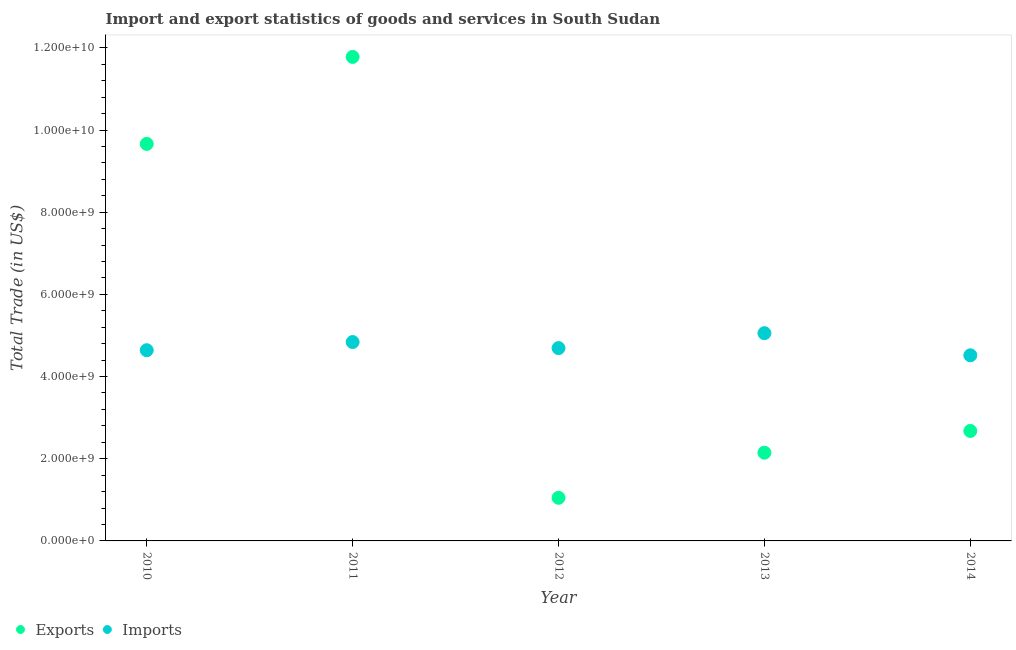How many different coloured dotlines are there?
Provide a short and direct response. 2. What is the imports of goods and services in 2012?
Give a very brief answer. 4.69e+09. Across all years, what is the maximum export of goods and services?
Your response must be concise. 1.18e+1. Across all years, what is the minimum imports of goods and services?
Your response must be concise. 4.52e+09. In which year was the imports of goods and services maximum?
Ensure brevity in your answer.  2013. What is the total export of goods and services in the graph?
Your answer should be very brief. 2.73e+1. What is the difference between the export of goods and services in 2010 and that in 2014?
Your answer should be very brief. 6.99e+09. What is the difference between the export of goods and services in 2011 and the imports of goods and services in 2014?
Provide a short and direct response. 7.26e+09. What is the average imports of goods and services per year?
Your answer should be very brief. 4.75e+09. In the year 2010, what is the difference between the imports of goods and services and export of goods and services?
Your answer should be very brief. -5.02e+09. What is the ratio of the imports of goods and services in 2010 to that in 2014?
Make the answer very short. 1.03. Is the difference between the imports of goods and services in 2012 and 2013 greater than the difference between the export of goods and services in 2012 and 2013?
Offer a terse response. Yes. What is the difference between the highest and the second highest export of goods and services?
Provide a succinct answer. 2.12e+09. What is the difference between the highest and the lowest export of goods and services?
Your answer should be compact. 1.07e+1. How many dotlines are there?
Make the answer very short. 2. How many years are there in the graph?
Your answer should be compact. 5. What is the difference between two consecutive major ticks on the Y-axis?
Your answer should be compact. 2.00e+09. Are the values on the major ticks of Y-axis written in scientific E-notation?
Make the answer very short. Yes. How many legend labels are there?
Give a very brief answer. 2. What is the title of the graph?
Your answer should be very brief. Import and export statistics of goods and services in South Sudan. What is the label or title of the Y-axis?
Provide a short and direct response. Total Trade (in US$). What is the Total Trade (in US$) in Exports in 2010?
Your answer should be very brief. 9.66e+09. What is the Total Trade (in US$) of Imports in 2010?
Your response must be concise. 4.64e+09. What is the Total Trade (in US$) of Exports in 2011?
Make the answer very short. 1.18e+1. What is the Total Trade (in US$) in Imports in 2011?
Your answer should be compact. 4.84e+09. What is the Total Trade (in US$) of Exports in 2012?
Your response must be concise. 1.05e+09. What is the Total Trade (in US$) in Imports in 2012?
Make the answer very short. 4.69e+09. What is the Total Trade (in US$) in Exports in 2013?
Your response must be concise. 2.15e+09. What is the Total Trade (in US$) in Imports in 2013?
Give a very brief answer. 5.06e+09. What is the Total Trade (in US$) of Exports in 2014?
Provide a succinct answer. 2.68e+09. What is the Total Trade (in US$) of Imports in 2014?
Your answer should be very brief. 4.52e+09. Across all years, what is the maximum Total Trade (in US$) in Exports?
Your answer should be compact. 1.18e+1. Across all years, what is the maximum Total Trade (in US$) in Imports?
Provide a succinct answer. 5.06e+09. Across all years, what is the minimum Total Trade (in US$) of Exports?
Offer a very short reply. 1.05e+09. Across all years, what is the minimum Total Trade (in US$) of Imports?
Provide a succinct answer. 4.52e+09. What is the total Total Trade (in US$) of Exports in the graph?
Offer a very short reply. 2.73e+1. What is the total Total Trade (in US$) in Imports in the graph?
Provide a short and direct response. 2.37e+1. What is the difference between the Total Trade (in US$) in Exports in 2010 and that in 2011?
Make the answer very short. -2.12e+09. What is the difference between the Total Trade (in US$) of Imports in 2010 and that in 2011?
Your response must be concise. -1.99e+08. What is the difference between the Total Trade (in US$) in Exports in 2010 and that in 2012?
Offer a terse response. 8.61e+09. What is the difference between the Total Trade (in US$) of Imports in 2010 and that in 2012?
Make the answer very short. -5.19e+07. What is the difference between the Total Trade (in US$) in Exports in 2010 and that in 2013?
Offer a very short reply. 7.51e+09. What is the difference between the Total Trade (in US$) in Imports in 2010 and that in 2013?
Make the answer very short. -4.15e+08. What is the difference between the Total Trade (in US$) of Exports in 2010 and that in 2014?
Your response must be concise. 6.99e+09. What is the difference between the Total Trade (in US$) in Imports in 2010 and that in 2014?
Ensure brevity in your answer.  1.23e+08. What is the difference between the Total Trade (in US$) of Exports in 2011 and that in 2012?
Provide a short and direct response. 1.07e+1. What is the difference between the Total Trade (in US$) of Imports in 2011 and that in 2012?
Provide a succinct answer. 1.47e+08. What is the difference between the Total Trade (in US$) in Exports in 2011 and that in 2013?
Provide a succinct answer. 9.63e+09. What is the difference between the Total Trade (in US$) of Imports in 2011 and that in 2013?
Provide a succinct answer. -2.16e+08. What is the difference between the Total Trade (in US$) of Exports in 2011 and that in 2014?
Ensure brevity in your answer.  9.10e+09. What is the difference between the Total Trade (in US$) in Imports in 2011 and that in 2014?
Offer a terse response. 3.22e+08. What is the difference between the Total Trade (in US$) of Exports in 2012 and that in 2013?
Offer a terse response. -1.10e+09. What is the difference between the Total Trade (in US$) in Imports in 2012 and that in 2013?
Keep it short and to the point. -3.63e+08. What is the difference between the Total Trade (in US$) of Exports in 2012 and that in 2014?
Your answer should be very brief. -1.63e+09. What is the difference between the Total Trade (in US$) of Imports in 2012 and that in 2014?
Your answer should be very brief. 1.75e+08. What is the difference between the Total Trade (in US$) in Exports in 2013 and that in 2014?
Make the answer very short. -5.29e+08. What is the difference between the Total Trade (in US$) in Imports in 2013 and that in 2014?
Your answer should be compact. 5.38e+08. What is the difference between the Total Trade (in US$) in Exports in 2010 and the Total Trade (in US$) in Imports in 2011?
Ensure brevity in your answer.  4.82e+09. What is the difference between the Total Trade (in US$) of Exports in 2010 and the Total Trade (in US$) of Imports in 2012?
Make the answer very short. 4.97e+09. What is the difference between the Total Trade (in US$) of Exports in 2010 and the Total Trade (in US$) of Imports in 2013?
Provide a succinct answer. 4.61e+09. What is the difference between the Total Trade (in US$) of Exports in 2010 and the Total Trade (in US$) of Imports in 2014?
Offer a very short reply. 5.14e+09. What is the difference between the Total Trade (in US$) in Exports in 2011 and the Total Trade (in US$) in Imports in 2012?
Provide a short and direct response. 7.09e+09. What is the difference between the Total Trade (in US$) of Exports in 2011 and the Total Trade (in US$) of Imports in 2013?
Offer a terse response. 6.72e+09. What is the difference between the Total Trade (in US$) of Exports in 2011 and the Total Trade (in US$) of Imports in 2014?
Provide a short and direct response. 7.26e+09. What is the difference between the Total Trade (in US$) in Exports in 2012 and the Total Trade (in US$) in Imports in 2013?
Your answer should be compact. -4.01e+09. What is the difference between the Total Trade (in US$) of Exports in 2012 and the Total Trade (in US$) of Imports in 2014?
Provide a short and direct response. -3.47e+09. What is the difference between the Total Trade (in US$) in Exports in 2013 and the Total Trade (in US$) in Imports in 2014?
Your response must be concise. -2.37e+09. What is the average Total Trade (in US$) in Exports per year?
Offer a very short reply. 5.46e+09. What is the average Total Trade (in US$) of Imports per year?
Offer a very short reply. 4.75e+09. In the year 2010, what is the difference between the Total Trade (in US$) of Exports and Total Trade (in US$) of Imports?
Your response must be concise. 5.02e+09. In the year 2011, what is the difference between the Total Trade (in US$) in Exports and Total Trade (in US$) in Imports?
Provide a short and direct response. 6.94e+09. In the year 2012, what is the difference between the Total Trade (in US$) of Exports and Total Trade (in US$) of Imports?
Offer a terse response. -3.64e+09. In the year 2013, what is the difference between the Total Trade (in US$) in Exports and Total Trade (in US$) in Imports?
Make the answer very short. -2.91e+09. In the year 2014, what is the difference between the Total Trade (in US$) in Exports and Total Trade (in US$) in Imports?
Offer a terse response. -1.84e+09. What is the ratio of the Total Trade (in US$) in Exports in 2010 to that in 2011?
Offer a very short reply. 0.82. What is the ratio of the Total Trade (in US$) of Imports in 2010 to that in 2011?
Give a very brief answer. 0.96. What is the ratio of the Total Trade (in US$) in Exports in 2010 to that in 2012?
Provide a short and direct response. 9.21. What is the ratio of the Total Trade (in US$) in Imports in 2010 to that in 2012?
Keep it short and to the point. 0.99. What is the ratio of the Total Trade (in US$) in Exports in 2010 to that in 2013?
Give a very brief answer. 4.5. What is the ratio of the Total Trade (in US$) in Imports in 2010 to that in 2013?
Give a very brief answer. 0.92. What is the ratio of the Total Trade (in US$) of Exports in 2010 to that in 2014?
Your response must be concise. 3.61. What is the ratio of the Total Trade (in US$) in Imports in 2010 to that in 2014?
Your answer should be compact. 1.03. What is the ratio of the Total Trade (in US$) of Exports in 2011 to that in 2012?
Your answer should be very brief. 11.22. What is the ratio of the Total Trade (in US$) in Imports in 2011 to that in 2012?
Your answer should be very brief. 1.03. What is the ratio of the Total Trade (in US$) of Exports in 2011 to that in 2013?
Your answer should be compact. 5.49. What is the ratio of the Total Trade (in US$) of Imports in 2011 to that in 2013?
Provide a short and direct response. 0.96. What is the ratio of the Total Trade (in US$) of Exports in 2011 to that in 2014?
Keep it short and to the point. 4.4. What is the ratio of the Total Trade (in US$) in Imports in 2011 to that in 2014?
Offer a very short reply. 1.07. What is the ratio of the Total Trade (in US$) in Exports in 2012 to that in 2013?
Your answer should be very brief. 0.49. What is the ratio of the Total Trade (in US$) in Imports in 2012 to that in 2013?
Provide a short and direct response. 0.93. What is the ratio of the Total Trade (in US$) in Exports in 2012 to that in 2014?
Your answer should be very brief. 0.39. What is the ratio of the Total Trade (in US$) in Imports in 2012 to that in 2014?
Offer a very short reply. 1.04. What is the ratio of the Total Trade (in US$) in Exports in 2013 to that in 2014?
Provide a short and direct response. 0.8. What is the ratio of the Total Trade (in US$) in Imports in 2013 to that in 2014?
Give a very brief answer. 1.12. What is the difference between the highest and the second highest Total Trade (in US$) in Exports?
Offer a terse response. 2.12e+09. What is the difference between the highest and the second highest Total Trade (in US$) in Imports?
Provide a short and direct response. 2.16e+08. What is the difference between the highest and the lowest Total Trade (in US$) of Exports?
Keep it short and to the point. 1.07e+1. What is the difference between the highest and the lowest Total Trade (in US$) of Imports?
Keep it short and to the point. 5.38e+08. 